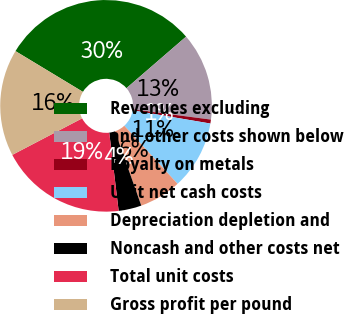Convert chart to OTSL. <chart><loc_0><loc_0><loc_500><loc_500><pie_chart><fcel>Revenues excluding<fcel>and other costs shown below<fcel>Royalty on metals<fcel>Unit net cash costs<fcel>Depreciation depletion and<fcel>Noncash and other costs net<fcel>Total unit costs<fcel>Gross profit per pound<nl><fcel>30.0%<fcel>13.42%<fcel>0.6%<fcel>10.51%<fcel>6.41%<fcel>3.5%<fcel>19.23%<fcel>16.32%<nl></chart> 